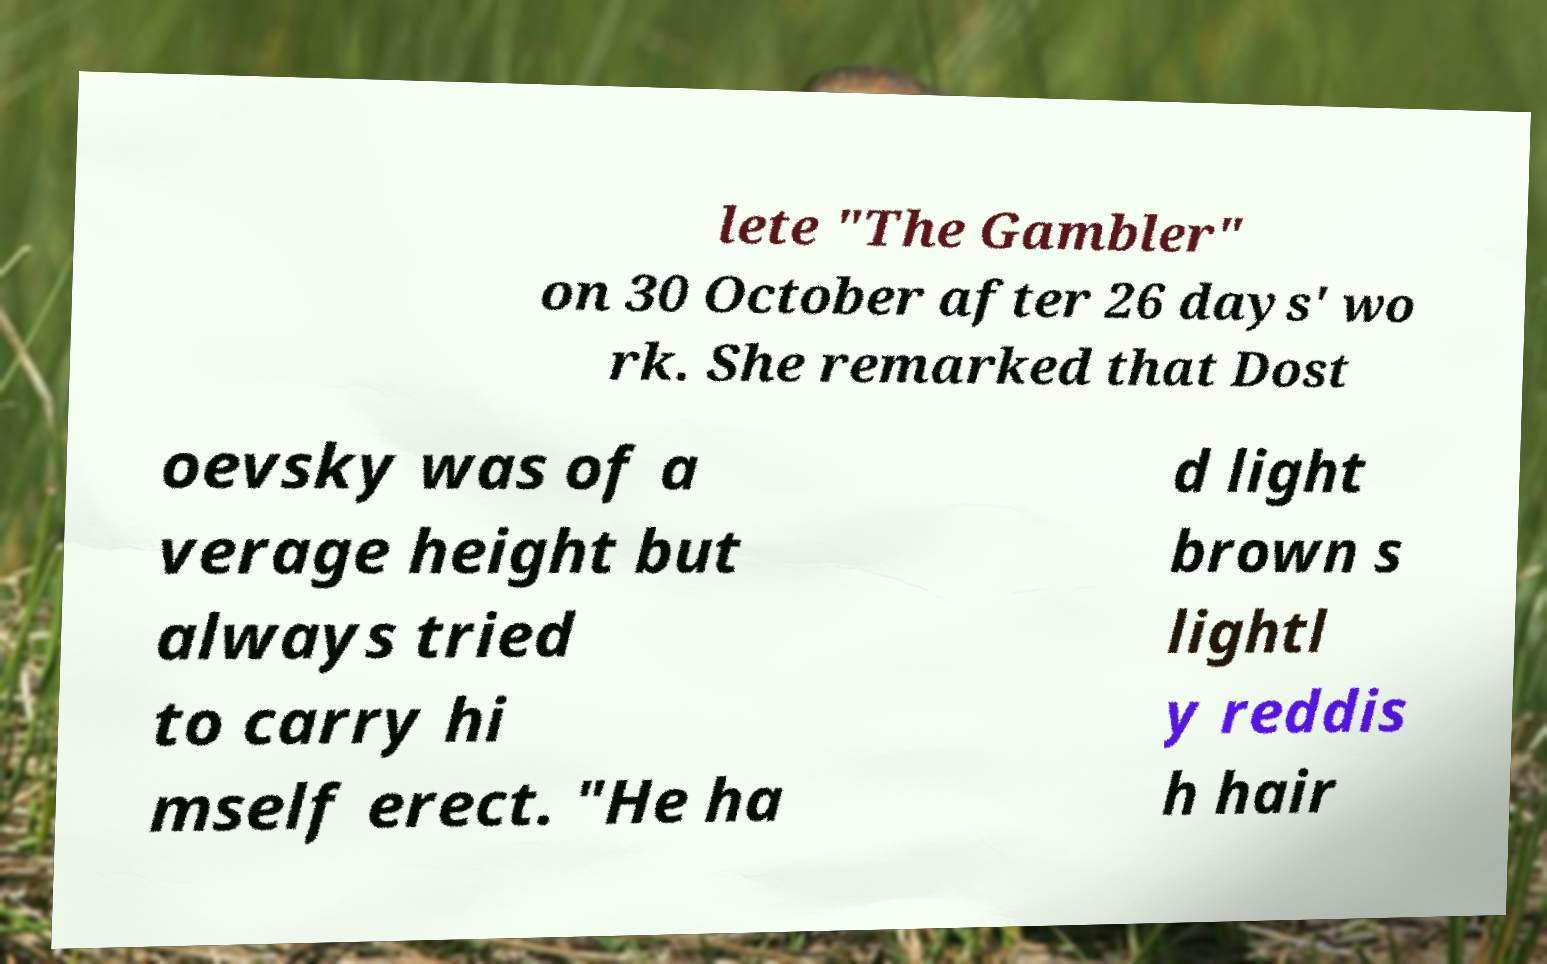Can you read and provide the text displayed in the image?This photo seems to have some interesting text. Can you extract and type it out for me? lete "The Gambler" on 30 October after 26 days' wo rk. She remarked that Dost oevsky was of a verage height but always tried to carry hi mself erect. "He ha d light brown s lightl y reddis h hair 